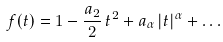<formula> <loc_0><loc_0><loc_500><loc_500>f ( t ) = 1 - \frac { a _ { 2 } } { 2 } \, t ^ { 2 } + a _ { \alpha } \, | t | ^ { \alpha } + \dots</formula> 